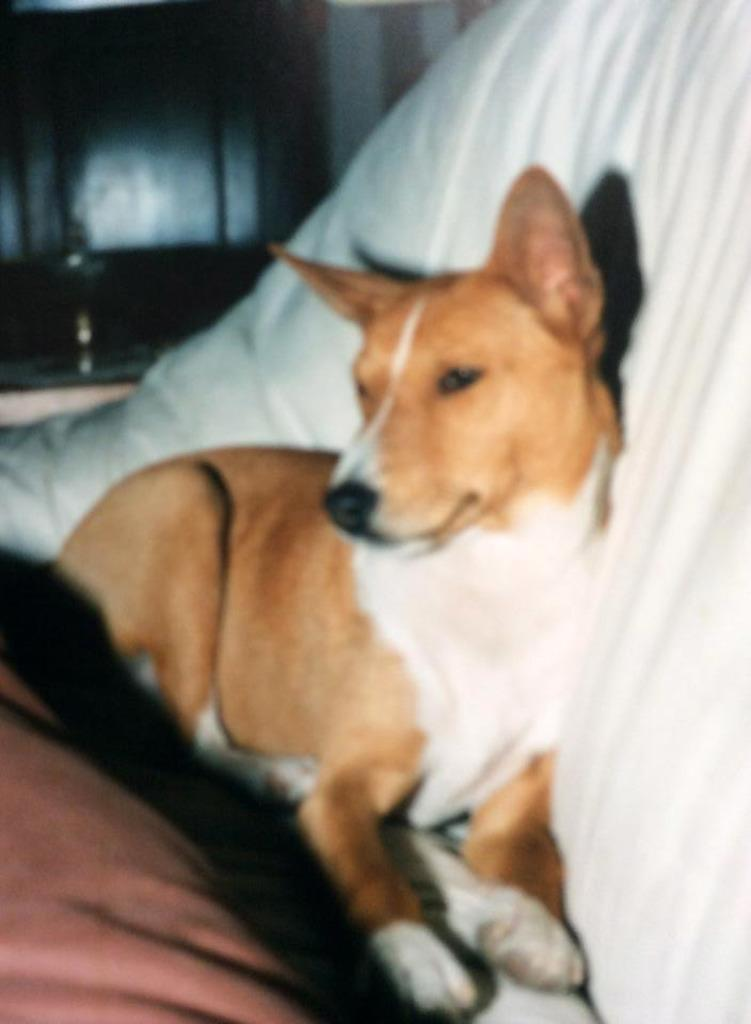What type of animal is in the image? There is a dog in the image. Where is the dog located? The dog is on a sofa. What type of engine is visible in the image? There is no engine present in the image; it features a dog on a sofa. What type of teeth can be seen in the image? The image does not show any teeth, as it features a dog on a sofa. 